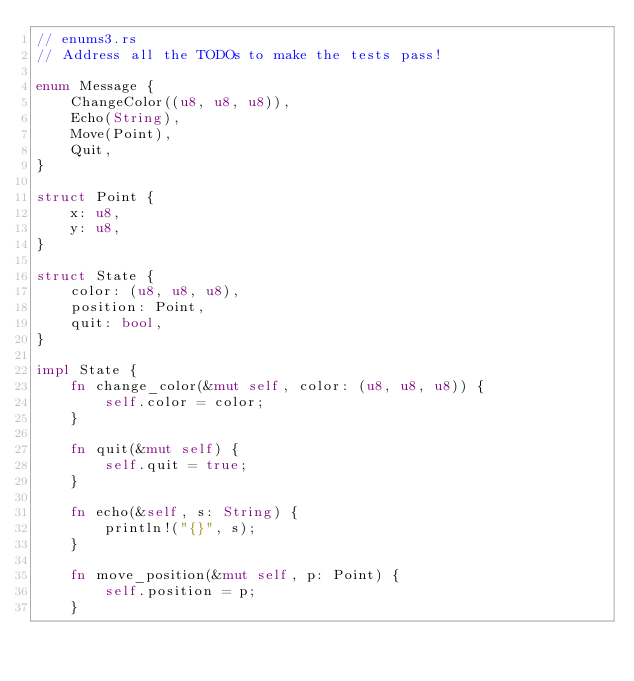Convert code to text. <code><loc_0><loc_0><loc_500><loc_500><_Rust_>// enums3.rs
// Address all the TODOs to make the tests pass!

enum Message {
    ChangeColor((u8, u8, u8)),
    Echo(String),
    Move(Point),
    Quit,
}

struct Point {
    x: u8,
    y: u8,
}

struct State {
    color: (u8, u8, u8),
    position: Point,
    quit: bool,
}

impl State {
    fn change_color(&mut self, color: (u8, u8, u8)) {
        self.color = color;
    }

    fn quit(&mut self) {
        self.quit = true;
    }

    fn echo(&self, s: String) {
        println!("{}", s);
    }

    fn move_position(&mut self, p: Point) {
        self.position = p;
    }
</code> 